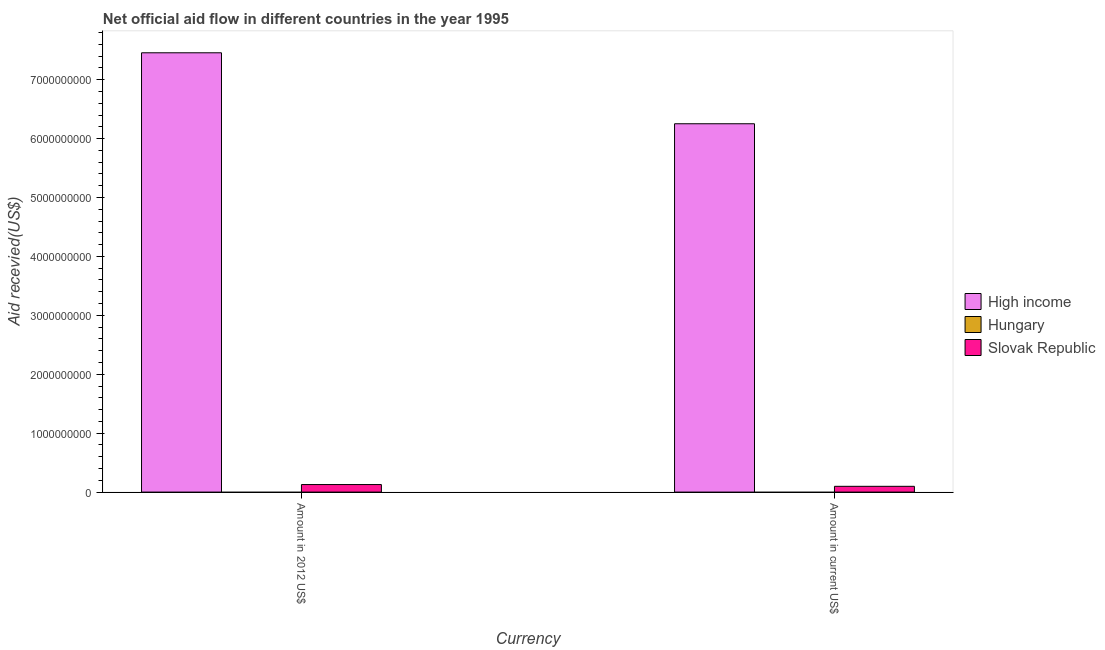Are the number of bars per tick equal to the number of legend labels?
Make the answer very short. No. How many bars are there on the 2nd tick from the left?
Your answer should be compact. 2. How many bars are there on the 2nd tick from the right?
Offer a terse response. 2. What is the label of the 2nd group of bars from the left?
Your response must be concise. Amount in current US$. What is the amount of aid received(expressed in 2012 us$) in Hungary?
Your response must be concise. 0. Across all countries, what is the maximum amount of aid received(expressed in 2012 us$)?
Provide a short and direct response. 7.46e+09. Across all countries, what is the minimum amount of aid received(expressed in 2012 us$)?
Keep it short and to the point. 0. In which country was the amount of aid received(expressed in us$) maximum?
Your answer should be compact. High income. What is the total amount of aid received(expressed in us$) in the graph?
Ensure brevity in your answer.  6.35e+09. What is the difference between the amount of aid received(expressed in 2012 us$) in High income and that in Slovak Republic?
Make the answer very short. 7.33e+09. What is the difference between the amount of aid received(expressed in us$) in Hungary and the amount of aid received(expressed in 2012 us$) in Slovak Republic?
Make the answer very short. -1.28e+08. What is the average amount of aid received(expressed in us$) per country?
Your response must be concise. 2.12e+09. What is the difference between the amount of aid received(expressed in 2012 us$) and amount of aid received(expressed in us$) in High income?
Make the answer very short. 1.20e+09. In how many countries, is the amount of aid received(expressed in 2012 us$) greater than 7400000000 US$?
Offer a terse response. 1. What is the ratio of the amount of aid received(expressed in 2012 us$) in Slovak Republic to that in High income?
Make the answer very short. 0.02. Is the amount of aid received(expressed in us$) in High income less than that in Slovak Republic?
Ensure brevity in your answer.  No. In how many countries, is the amount of aid received(expressed in 2012 us$) greater than the average amount of aid received(expressed in 2012 us$) taken over all countries?
Make the answer very short. 1. How many bars are there?
Provide a short and direct response. 4. Are all the bars in the graph horizontal?
Your response must be concise. No. Are the values on the major ticks of Y-axis written in scientific E-notation?
Make the answer very short. No. Where does the legend appear in the graph?
Your answer should be very brief. Center right. How many legend labels are there?
Provide a succinct answer. 3. What is the title of the graph?
Keep it short and to the point. Net official aid flow in different countries in the year 1995. Does "Romania" appear as one of the legend labels in the graph?
Give a very brief answer. No. What is the label or title of the X-axis?
Make the answer very short. Currency. What is the label or title of the Y-axis?
Give a very brief answer. Aid recevied(US$). What is the Aid recevied(US$) of High income in Amount in 2012 US$?
Keep it short and to the point. 7.46e+09. What is the Aid recevied(US$) in Slovak Republic in Amount in 2012 US$?
Provide a succinct answer. 1.28e+08. What is the Aid recevied(US$) in High income in Amount in current US$?
Ensure brevity in your answer.  6.25e+09. What is the Aid recevied(US$) in Hungary in Amount in current US$?
Offer a terse response. 0. What is the Aid recevied(US$) in Slovak Republic in Amount in current US$?
Keep it short and to the point. 9.80e+07. Across all Currency, what is the maximum Aid recevied(US$) in High income?
Ensure brevity in your answer.  7.46e+09. Across all Currency, what is the maximum Aid recevied(US$) of Slovak Republic?
Make the answer very short. 1.28e+08. Across all Currency, what is the minimum Aid recevied(US$) of High income?
Ensure brevity in your answer.  6.25e+09. Across all Currency, what is the minimum Aid recevied(US$) of Slovak Republic?
Provide a succinct answer. 9.80e+07. What is the total Aid recevied(US$) of High income in the graph?
Ensure brevity in your answer.  1.37e+1. What is the total Aid recevied(US$) of Slovak Republic in the graph?
Offer a very short reply. 2.26e+08. What is the difference between the Aid recevied(US$) in High income in Amount in 2012 US$ and that in Amount in current US$?
Keep it short and to the point. 1.20e+09. What is the difference between the Aid recevied(US$) in Slovak Republic in Amount in 2012 US$ and that in Amount in current US$?
Provide a succinct answer. 3.00e+07. What is the difference between the Aid recevied(US$) in High income in Amount in 2012 US$ and the Aid recevied(US$) in Slovak Republic in Amount in current US$?
Give a very brief answer. 7.36e+09. What is the average Aid recevied(US$) of High income per Currency?
Keep it short and to the point. 6.85e+09. What is the average Aid recevied(US$) in Hungary per Currency?
Offer a terse response. 0. What is the average Aid recevied(US$) in Slovak Republic per Currency?
Give a very brief answer. 1.13e+08. What is the difference between the Aid recevied(US$) of High income and Aid recevied(US$) of Slovak Republic in Amount in 2012 US$?
Your answer should be compact. 7.33e+09. What is the difference between the Aid recevied(US$) in High income and Aid recevied(US$) in Slovak Republic in Amount in current US$?
Your response must be concise. 6.15e+09. What is the ratio of the Aid recevied(US$) in High income in Amount in 2012 US$ to that in Amount in current US$?
Ensure brevity in your answer.  1.19. What is the ratio of the Aid recevied(US$) of Slovak Republic in Amount in 2012 US$ to that in Amount in current US$?
Offer a very short reply. 1.31. What is the difference between the highest and the second highest Aid recevied(US$) of High income?
Provide a succinct answer. 1.20e+09. What is the difference between the highest and the second highest Aid recevied(US$) in Slovak Republic?
Make the answer very short. 3.00e+07. What is the difference between the highest and the lowest Aid recevied(US$) of High income?
Give a very brief answer. 1.20e+09. What is the difference between the highest and the lowest Aid recevied(US$) in Slovak Republic?
Give a very brief answer. 3.00e+07. 